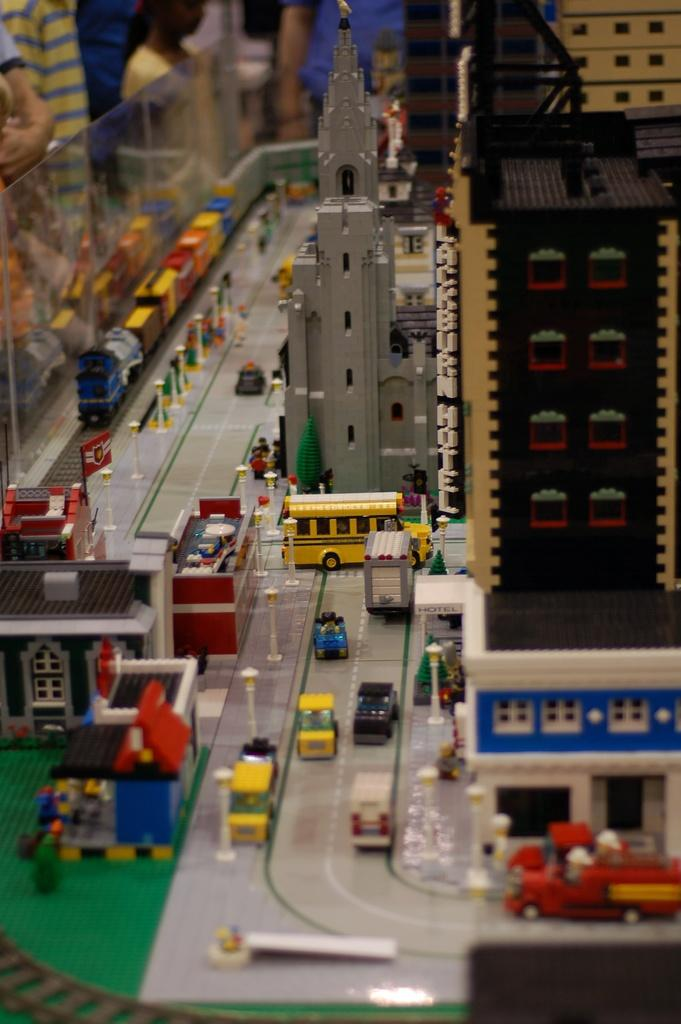What type of structures can be seen in the image? There are buildings in the image. What else can be seen in the image besides buildings? There is a road and vehicles visible in the image. Can you describe the train in the image? The train in the image is made with legos. Where are the persons located in the image? The persons are present at the top left corner of the image. Can you see a squirrel climbing the wall in the image? There is no squirrel or wall present in the image. Is there a bath visible in the image? There is no bath present in the image. 